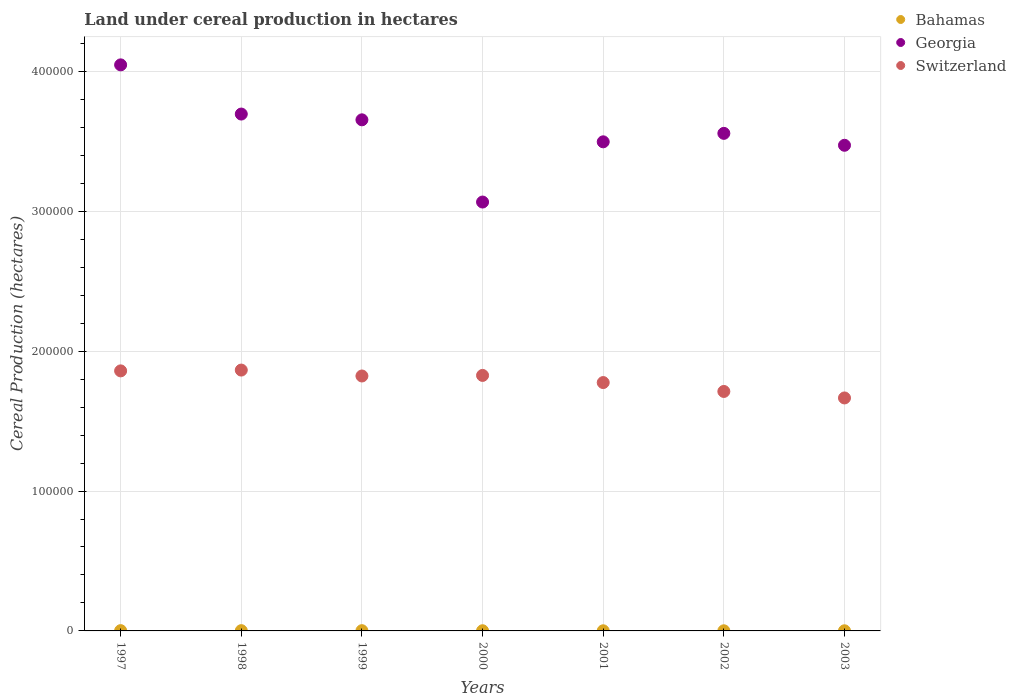What is the land under cereal production in Bahamas in 1998?
Ensure brevity in your answer.  190. Across all years, what is the maximum land under cereal production in Bahamas?
Make the answer very short. 200. Across all years, what is the minimum land under cereal production in Bahamas?
Keep it short and to the point. 100. In which year was the land under cereal production in Switzerland maximum?
Keep it short and to the point. 1998. What is the total land under cereal production in Georgia in the graph?
Provide a short and direct response. 2.50e+06. What is the difference between the land under cereal production in Bahamas in 1997 and that in 2002?
Your answer should be compact. 100. What is the difference between the land under cereal production in Bahamas in 1999 and the land under cereal production in Switzerland in 2001?
Provide a short and direct response. -1.77e+05. What is the average land under cereal production in Georgia per year?
Offer a terse response. 3.57e+05. In the year 2000, what is the difference between the land under cereal production in Georgia and land under cereal production in Switzerland?
Ensure brevity in your answer.  1.24e+05. What is the ratio of the land under cereal production in Georgia in 1998 to that in 1999?
Provide a short and direct response. 1.01. Is the difference between the land under cereal production in Georgia in 1999 and 2000 greater than the difference between the land under cereal production in Switzerland in 1999 and 2000?
Provide a succinct answer. Yes. What is the difference between the highest and the second highest land under cereal production in Switzerland?
Ensure brevity in your answer.  582. What is the difference between the highest and the lowest land under cereal production in Switzerland?
Provide a succinct answer. 1.99e+04. In how many years, is the land under cereal production in Georgia greater than the average land under cereal production in Georgia taken over all years?
Provide a succinct answer. 3. Is it the case that in every year, the sum of the land under cereal production in Bahamas and land under cereal production in Georgia  is greater than the land under cereal production in Switzerland?
Keep it short and to the point. Yes. Is the land under cereal production in Switzerland strictly greater than the land under cereal production in Georgia over the years?
Keep it short and to the point. No. Is the land under cereal production in Georgia strictly less than the land under cereal production in Bahamas over the years?
Your answer should be compact. No. How many dotlines are there?
Provide a short and direct response. 3. Are the values on the major ticks of Y-axis written in scientific E-notation?
Your answer should be compact. No. Does the graph contain any zero values?
Keep it short and to the point. No. Does the graph contain grids?
Offer a terse response. Yes. Where does the legend appear in the graph?
Give a very brief answer. Top right. How many legend labels are there?
Your response must be concise. 3. How are the legend labels stacked?
Offer a very short reply. Vertical. What is the title of the graph?
Offer a very short reply. Land under cereal production in hectares. What is the label or title of the Y-axis?
Provide a short and direct response. Cereal Production (hectares). What is the Cereal Production (hectares) in Georgia in 1997?
Provide a succinct answer. 4.05e+05. What is the Cereal Production (hectares) in Switzerland in 1997?
Provide a succinct answer. 1.86e+05. What is the Cereal Production (hectares) of Bahamas in 1998?
Provide a short and direct response. 190. What is the Cereal Production (hectares) in Georgia in 1998?
Your answer should be very brief. 3.70e+05. What is the Cereal Production (hectares) in Switzerland in 1998?
Offer a terse response. 1.86e+05. What is the Cereal Production (hectares) of Bahamas in 1999?
Ensure brevity in your answer.  175. What is the Cereal Production (hectares) in Georgia in 1999?
Offer a very short reply. 3.65e+05. What is the Cereal Production (hectares) in Switzerland in 1999?
Your response must be concise. 1.82e+05. What is the Cereal Production (hectares) of Bahamas in 2000?
Your answer should be compact. 126. What is the Cereal Production (hectares) in Georgia in 2000?
Offer a terse response. 3.07e+05. What is the Cereal Production (hectares) in Switzerland in 2000?
Offer a very short reply. 1.83e+05. What is the Cereal Production (hectares) in Georgia in 2001?
Offer a very short reply. 3.50e+05. What is the Cereal Production (hectares) of Switzerland in 2001?
Offer a terse response. 1.78e+05. What is the Cereal Production (hectares) in Bahamas in 2002?
Offer a terse response. 100. What is the Cereal Production (hectares) in Georgia in 2002?
Keep it short and to the point. 3.56e+05. What is the Cereal Production (hectares) in Switzerland in 2002?
Make the answer very short. 1.71e+05. What is the Cereal Production (hectares) in Georgia in 2003?
Give a very brief answer. 3.47e+05. What is the Cereal Production (hectares) of Switzerland in 2003?
Ensure brevity in your answer.  1.67e+05. Across all years, what is the maximum Cereal Production (hectares) of Bahamas?
Provide a short and direct response. 200. Across all years, what is the maximum Cereal Production (hectares) in Georgia?
Offer a terse response. 4.05e+05. Across all years, what is the maximum Cereal Production (hectares) of Switzerland?
Give a very brief answer. 1.86e+05. Across all years, what is the minimum Cereal Production (hectares) in Georgia?
Give a very brief answer. 3.07e+05. Across all years, what is the minimum Cereal Production (hectares) in Switzerland?
Your answer should be compact. 1.67e+05. What is the total Cereal Production (hectares) of Bahamas in the graph?
Offer a very short reply. 991. What is the total Cereal Production (hectares) of Georgia in the graph?
Your answer should be very brief. 2.50e+06. What is the total Cereal Production (hectares) of Switzerland in the graph?
Provide a short and direct response. 1.25e+06. What is the difference between the Cereal Production (hectares) of Georgia in 1997 and that in 1998?
Make the answer very short. 3.52e+04. What is the difference between the Cereal Production (hectares) of Switzerland in 1997 and that in 1998?
Make the answer very short. -582. What is the difference between the Cereal Production (hectares) in Bahamas in 1997 and that in 1999?
Provide a succinct answer. 25. What is the difference between the Cereal Production (hectares) in Georgia in 1997 and that in 1999?
Your answer should be compact. 3.93e+04. What is the difference between the Cereal Production (hectares) of Switzerland in 1997 and that in 1999?
Your answer should be compact. 3652. What is the difference between the Cereal Production (hectares) in Georgia in 1997 and that in 2000?
Your response must be concise. 9.81e+04. What is the difference between the Cereal Production (hectares) of Switzerland in 1997 and that in 2000?
Your response must be concise. 3243. What is the difference between the Cereal Production (hectares) in Bahamas in 1997 and that in 2001?
Offer a very short reply. 100. What is the difference between the Cereal Production (hectares) of Georgia in 1997 and that in 2001?
Offer a very short reply. 5.50e+04. What is the difference between the Cereal Production (hectares) in Switzerland in 1997 and that in 2001?
Ensure brevity in your answer.  8353. What is the difference between the Cereal Production (hectares) of Georgia in 1997 and that in 2002?
Your response must be concise. 4.90e+04. What is the difference between the Cereal Production (hectares) of Switzerland in 1997 and that in 2002?
Provide a short and direct response. 1.47e+04. What is the difference between the Cereal Production (hectares) of Georgia in 1997 and that in 2003?
Ensure brevity in your answer.  5.75e+04. What is the difference between the Cereal Production (hectares) in Switzerland in 1997 and that in 2003?
Make the answer very short. 1.94e+04. What is the difference between the Cereal Production (hectares) in Bahamas in 1998 and that in 1999?
Give a very brief answer. 15. What is the difference between the Cereal Production (hectares) in Georgia in 1998 and that in 1999?
Keep it short and to the point. 4126. What is the difference between the Cereal Production (hectares) of Switzerland in 1998 and that in 1999?
Offer a terse response. 4234. What is the difference between the Cereal Production (hectares) in Georgia in 1998 and that in 2000?
Make the answer very short. 6.29e+04. What is the difference between the Cereal Production (hectares) of Switzerland in 1998 and that in 2000?
Make the answer very short. 3825. What is the difference between the Cereal Production (hectares) in Georgia in 1998 and that in 2001?
Provide a succinct answer. 1.99e+04. What is the difference between the Cereal Production (hectares) of Switzerland in 1998 and that in 2001?
Offer a terse response. 8935. What is the difference between the Cereal Production (hectares) of Bahamas in 1998 and that in 2002?
Your response must be concise. 90. What is the difference between the Cereal Production (hectares) in Georgia in 1998 and that in 2002?
Make the answer very short. 1.38e+04. What is the difference between the Cereal Production (hectares) of Switzerland in 1998 and that in 2002?
Your answer should be compact. 1.53e+04. What is the difference between the Cereal Production (hectares) in Bahamas in 1998 and that in 2003?
Keep it short and to the point. 90. What is the difference between the Cereal Production (hectares) of Georgia in 1998 and that in 2003?
Provide a short and direct response. 2.23e+04. What is the difference between the Cereal Production (hectares) in Switzerland in 1998 and that in 2003?
Your response must be concise. 1.99e+04. What is the difference between the Cereal Production (hectares) of Bahamas in 1999 and that in 2000?
Make the answer very short. 49. What is the difference between the Cereal Production (hectares) of Georgia in 1999 and that in 2000?
Offer a terse response. 5.88e+04. What is the difference between the Cereal Production (hectares) of Switzerland in 1999 and that in 2000?
Provide a succinct answer. -409. What is the difference between the Cereal Production (hectares) of Bahamas in 1999 and that in 2001?
Provide a succinct answer. 75. What is the difference between the Cereal Production (hectares) in Georgia in 1999 and that in 2001?
Your answer should be compact. 1.57e+04. What is the difference between the Cereal Production (hectares) in Switzerland in 1999 and that in 2001?
Offer a terse response. 4701. What is the difference between the Cereal Production (hectares) of Georgia in 1999 and that in 2002?
Your answer should be very brief. 9676. What is the difference between the Cereal Production (hectares) in Switzerland in 1999 and that in 2002?
Give a very brief answer. 1.11e+04. What is the difference between the Cereal Production (hectares) of Georgia in 1999 and that in 2003?
Your response must be concise. 1.82e+04. What is the difference between the Cereal Production (hectares) of Switzerland in 1999 and that in 2003?
Make the answer very short. 1.57e+04. What is the difference between the Cereal Production (hectares) in Georgia in 2000 and that in 2001?
Give a very brief answer. -4.31e+04. What is the difference between the Cereal Production (hectares) in Switzerland in 2000 and that in 2001?
Your response must be concise. 5110. What is the difference between the Cereal Production (hectares) in Bahamas in 2000 and that in 2002?
Your response must be concise. 26. What is the difference between the Cereal Production (hectares) of Georgia in 2000 and that in 2002?
Provide a short and direct response. -4.91e+04. What is the difference between the Cereal Production (hectares) of Switzerland in 2000 and that in 2002?
Your answer should be compact. 1.15e+04. What is the difference between the Cereal Production (hectares) in Georgia in 2000 and that in 2003?
Provide a short and direct response. -4.06e+04. What is the difference between the Cereal Production (hectares) in Switzerland in 2000 and that in 2003?
Offer a very short reply. 1.61e+04. What is the difference between the Cereal Production (hectares) in Bahamas in 2001 and that in 2002?
Offer a very short reply. 0. What is the difference between the Cereal Production (hectares) in Georgia in 2001 and that in 2002?
Provide a short and direct response. -6049. What is the difference between the Cereal Production (hectares) of Switzerland in 2001 and that in 2002?
Provide a succinct answer. 6356. What is the difference between the Cereal Production (hectares) in Bahamas in 2001 and that in 2003?
Keep it short and to the point. 0. What is the difference between the Cereal Production (hectares) in Georgia in 2001 and that in 2003?
Your response must be concise. 2472. What is the difference between the Cereal Production (hectares) in Switzerland in 2001 and that in 2003?
Give a very brief answer. 1.10e+04. What is the difference between the Cereal Production (hectares) of Georgia in 2002 and that in 2003?
Your answer should be very brief. 8521. What is the difference between the Cereal Production (hectares) in Switzerland in 2002 and that in 2003?
Ensure brevity in your answer.  4642. What is the difference between the Cereal Production (hectares) in Bahamas in 1997 and the Cereal Production (hectares) in Georgia in 1998?
Provide a succinct answer. -3.69e+05. What is the difference between the Cereal Production (hectares) of Bahamas in 1997 and the Cereal Production (hectares) of Switzerland in 1998?
Offer a very short reply. -1.86e+05. What is the difference between the Cereal Production (hectares) of Georgia in 1997 and the Cereal Production (hectares) of Switzerland in 1998?
Provide a short and direct response. 2.18e+05. What is the difference between the Cereal Production (hectares) of Bahamas in 1997 and the Cereal Production (hectares) of Georgia in 1999?
Provide a short and direct response. -3.65e+05. What is the difference between the Cereal Production (hectares) in Bahamas in 1997 and the Cereal Production (hectares) in Switzerland in 1999?
Your answer should be very brief. -1.82e+05. What is the difference between the Cereal Production (hectares) in Georgia in 1997 and the Cereal Production (hectares) in Switzerland in 1999?
Keep it short and to the point. 2.22e+05. What is the difference between the Cereal Production (hectares) of Bahamas in 1997 and the Cereal Production (hectares) of Georgia in 2000?
Give a very brief answer. -3.06e+05. What is the difference between the Cereal Production (hectares) of Bahamas in 1997 and the Cereal Production (hectares) of Switzerland in 2000?
Ensure brevity in your answer.  -1.82e+05. What is the difference between the Cereal Production (hectares) in Georgia in 1997 and the Cereal Production (hectares) in Switzerland in 2000?
Provide a succinct answer. 2.22e+05. What is the difference between the Cereal Production (hectares) of Bahamas in 1997 and the Cereal Production (hectares) of Georgia in 2001?
Your answer should be very brief. -3.49e+05. What is the difference between the Cereal Production (hectares) in Bahamas in 1997 and the Cereal Production (hectares) in Switzerland in 2001?
Make the answer very short. -1.77e+05. What is the difference between the Cereal Production (hectares) of Georgia in 1997 and the Cereal Production (hectares) of Switzerland in 2001?
Your response must be concise. 2.27e+05. What is the difference between the Cereal Production (hectares) of Bahamas in 1997 and the Cereal Production (hectares) of Georgia in 2002?
Your answer should be compact. -3.56e+05. What is the difference between the Cereal Production (hectares) in Bahamas in 1997 and the Cereal Production (hectares) in Switzerland in 2002?
Ensure brevity in your answer.  -1.71e+05. What is the difference between the Cereal Production (hectares) of Georgia in 1997 and the Cereal Production (hectares) of Switzerland in 2002?
Provide a short and direct response. 2.33e+05. What is the difference between the Cereal Production (hectares) in Bahamas in 1997 and the Cereal Production (hectares) in Georgia in 2003?
Give a very brief answer. -3.47e+05. What is the difference between the Cereal Production (hectares) in Bahamas in 1997 and the Cereal Production (hectares) in Switzerland in 2003?
Provide a succinct answer. -1.66e+05. What is the difference between the Cereal Production (hectares) in Georgia in 1997 and the Cereal Production (hectares) in Switzerland in 2003?
Your answer should be compact. 2.38e+05. What is the difference between the Cereal Production (hectares) of Bahamas in 1998 and the Cereal Production (hectares) of Georgia in 1999?
Give a very brief answer. -3.65e+05. What is the difference between the Cereal Production (hectares) in Bahamas in 1998 and the Cereal Production (hectares) in Switzerland in 1999?
Ensure brevity in your answer.  -1.82e+05. What is the difference between the Cereal Production (hectares) of Georgia in 1998 and the Cereal Production (hectares) of Switzerland in 1999?
Keep it short and to the point. 1.87e+05. What is the difference between the Cereal Production (hectares) of Bahamas in 1998 and the Cereal Production (hectares) of Georgia in 2000?
Your response must be concise. -3.06e+05. What is the difference between the Cereal Production (hectares) in Bahamas in 1998 and the Cereal Production (hectares) in Switzerland in 2000?
Your answer should be very brief. -1.82e+05. What is the difference between the Cereal Production (hectares) of Georgia in 1998 and the Cereal Production (hectares) of Switzerland in 2000?
Your response must be concise. 1.87e+05. What is the difference between the Cereal Production (hectares) in Bahamas in 1998 and the Cereal Production (hectares) in Georgia in 2001?
Offer a terse response. -3.49e+05. What is the difference between the Cereal Production (hectares) of Bahamas in 1998 and the Cereal Production (hectares) of Switzerland in 2001?
Give a very brief answer. -1.77e+05. What is the difference between the Cereal Production (hectares) of Georgia in 1998 and the Cereal Production (hectares) of Switzerland in 2001?
Provide a succinct answer. 1.92e+05. What is the difference between the Cereal Production (hectares) of Bahamas in 1998 and the Cereal Production (hectares) of Georgia in 2002?
Your response must be concise. -3.56e+05. What is the difference between the Cereal Production (hectares) of Bahamas in 1998 and the Cereal Production (hectares) of Switzerland in 2002?
Your answer should be compact. -1.71e+05. What is the difference between the Cereal Production (hectares) of Georgia in 1998 and the Cereal Production (hectares) of Switzerland in 2002?
Keep it short and to the point. 1.98e+05. What is the difference between the Cereal Production (hectares) of Bahamas in 1998 and the Cereal Production (hectares) of Georgia in 2003?
Your answer should be compact. -3.47e+05. What is the difference between the Cereal Production (hectares) in Bahamas in 1998 and the Cereal Production (hectares) in Switzerland in 2003?
Your response must be concise. -1.66e+05. What is the difference between the Cereal Production (hectares) of Georgia in 1998 and the Cereal Production (hectares) of Switzerland in 2003?
Your answer should be compact. 2.03e+05. What is the difference between the Cereal Production (hectares) of Bahamas in 1999 and the Cereal Production (hectares) of Georgia in 2000?
Offer a terse response. -3.06e+05. What is the difference between the Cereal Production (hectares) in Bahamas in 1999 and the Cereal Production (hectares) in Switzerland in 2000?
Keep it short and to the point. -1.82e+05. What is the difference between the Cereal Production (hectares) in Georgia in 1999 and the Cereal Production (hectares) in Switzerland in 2000?
Give a very brief answer. 1.83e+05. What is the difference between the Cereal Production (hectares) of Bahamas in 1999 and the Cereal Production (hectares) of Georgia in 2001?
Offer a terse response. -3.49e+05. What is the difference between the Cereal Production (hectares) in Bahamas in 1999 and the Cereal Production (hectares) in Switzerland in 2001?
Your answer should be very brief. -1.77e+05. What is the difference between the Cereal Production (hectares) in Georgia in 1999 and the Cereal Production (hectares) in Switzerland in 2001?
Keep it short and to the point. 1.88e+05. What is the difference between the Cereal Production (hectares) in Bahamas in 1999 and the Cereal Production (hectares) in Georgia in 2002?
Your answer should be very brief. -3.56e+05. What is the difference between the Cereal Production (hectares) in Bahamas in 1999 and the Cereal Production (hectares) in Switzerland in 2002?
Make the answer very short. -1.71e+05. What is the difference between the Cereal Production (hectares) of Georgia in 1999 and the Cereal Production (hectares) of Switzerland in 2002?
Give a very brief answer. 1.94e+05. What is the difference between the Cereal Production (hectares) in Bahamas in 1999 and the Cereal Production (hectares) in Georgia in 2003?
Your answer should be very brief. -3.47e+05. What is the difference between the Cereal Production (hectares) of Bahamas in 1999 and the Cereal Production (hectares) of Switzerland in 2003?
Your answer should be compact. -1.66e+05. What is the difference between the Cereal Production (hectares) of Georgia in 1999 and the Cereal Production (hectares) of Switzerland in 2003?
Provide a succinct answer. 1.99e+05. What is the difference between the Cereal Production (hectares) in Bahamas in 2000 and the Cereal Production (hectares) in Georgia in 2001?
Your answer should be very brief. -3.50e+05. What is the difference between the Cereal Production (hectares) in Bahamas in 2000 and the Cereal Production (hectares) in Switzerland in 2001?
Make the answer very short. -1.77e+05. What is the difference between the Cereal Production (hectares) of Georgia in 2000 and the Cereal Production (hectares) of Switzerland in 2001?
Provide a short and direct response. 1.29e+05. What is the difference between the Cereal Production (hectares) of Bahamas in 2000 and the Cereal Production (hectares) of Georgia in 2002?
Give a very brief answer. -3.56e+05. What is the difference between the Cereal Production (hectares) in Bahamas in 2000 and the Cereal Production (hectares) in Switzerland in 2002?
Make the answer very short. -1.71e+05. What is the difference between the Cereal Production (hectares) of Georgia in 2000 and the Cereal Production (hectares) of Switzerland in 2002?
Your answer should be compact. 1.35e+05. What is the difference between the Cereal Production (hectares) of Bahamas in 2000 and the Cereal Production (hectares) of Georgia in 2003?
Give a very brief answer. -3.47e+05. What is the difference between the Cereal Production (hectares) in Bahamas in 2000 and the Cereal Production (hectares) in Switzerland in 2003?
Give a very brief answer. -1.66e+05. What is the difference between the Cereal Production (hectares) of Georgia in 2000 and the Cereal Production (hectares) of Switzerland in 2003?
Your answer should be very brief. 1.40e+05. What is the difference between the Cereal Production (hectares) in Bahamas in 2001 and the Cereal Production (hectares) in Georgia in 2002?
Provide a succinct answer. -3.56e+05. What is the difference between the Cereal Production (hectares) of Bahamas in 2001 and the Cereal Production (hectares) of Switzerland in 2002?
Make the answer very short. -1.71e+05. What is the difference between the Cereal Production (hectares) in Georgia in 2001 and the Cereal Production (hectares) in Switzerland in 2002?
Keep it short and to the point. 1.78e+05. What is the difference between the Cereal Production (hectares) in Bahamas in 2001 and the Cereal Production (hectares) in Georgia in 2003?
Ensure brevity in your answer.  -3.47e+05. What is the difference between the Cereal Production (hectares) in Bahamas in 2001 and the Cereal Production (hectares) in Switzerland in 2003?
Your answer should be very brief. -1.66e+05. What is the difference between the Cereal Production (hectares) in Georgia in 2001 and the Cereal Production (hectares) in Switzerland in 2003?
Provide a succinct answer. 1.83e+05. What is the difference between the Cereal Production (hectares) of Bahamas in 2002 and the Cereal Production (hectares) of Georgia in 2003?
Provide a succinct answer. -3.47e+05. What is the difference between the Cereal Production (hectares) in Bahamas in 2002 and the Cereal Production (hectares) in Switzerland in 2003?
Ensure brevity in your answer.  -1.66e+05. What is the difference between the Cereal Production (hectares) in Georgia in 2002 and the Cereal Production (hectares) in Switzerland in 2003?
Your response must be concise. 1.89e+05. What is the average Cereal Production (hectares) in Bahamas per year?
Your response must be concise. 141.57. What is the average Cereal Production (hectares) of Georgia per year?
Provide a succinct answer. 3.57e+05. What is the average Cereal Production (hectares) in Switzerland per year?
Your answer should be very brief. 1.79e+05. In the year 1997, what is the difference between the Cereal Production (hectares) of Bahamas and Cereal Production (hectares) of Georgia?
Give a very brief answer. -4.04e+05. In the year 1997, what is the difference between the Cereal Production (hectares) of Bahamas and Cereal Production (hectares) of Switzerland?
Provide a succinct answer. -1.86e+05. In the year 1997, what is the difference between the Cereal Production (hectares) in Georgia and Cereal Production (hectares) in Switzerland?
Provide a short and direct response. 2.19e+05. In the year 1998, what is the difference between the Cereal Production (hectares) in Bahamas and Cereal Production (hectares) in Georgia?
Your answer should be compact. -3.69e+05. In the year 1998, what is the difference between the Cereal Production (hectares) in Bahamas and Cereal Production (hectares) in Switzerland?
Ensure brevity in your answer.  -1.86e+05. In the year 1998, what is the difference between the Cereal Production (hectares) in Georgia and Cereal Production (hectares) in Switzerland?
Make the answer very short. 1.83e+05. In the year 1999, what is the difference between the Cereal Production (hectares) of Bahamas and Cereal Production (hectares) of Georgia?
Keep it short and to the point. -3.65e+05. In the year 1999, what is the difference between the Cereal Production (hectares) in Bahamas and Cereal Production (hectares) in Switzerland?
Make the answer very short. -1.82e+05. In the year 1999, what is the difference between the Cereal Production (hectares) of Georgia and Cereal Production (hectares) of Switzerland?
Provide a succinct answer. 1.83e+05. In the year 2000, what is the difference between the Cereal Production (hectares) of Bahamas and Cereal Production (hectares) of Georgia?
Give a very brief answer. -3.06e+05. In the year 2000, what is the difference between the Cereal Production (hectares) in Bahamas and Cereal Production (hectares) in Switzerland?
Offer a very short reply. -1.83e+05. In the year 2000, what is the difference between the Cereal Production (hectares) of Georgia and Cereal Production (hectares) of Switzerland?
Your answer should be compact. 1.24e+05. In the year 2001, what is the difference between the Cereal Production (hectares) in Bahamas and Cereal Production (hectares) in Georgia?
Make the answer very short. -3.50e+05. In the year 2001, what is the difference between the Cereal Production (hectares) in Bahamas and Cereal Production (hectares) in Switzerland?
Make the answer very short. -1.77e+05. In the year 2001, what is the difference between the Cereal Production (hectares) of Georgia and Cereal Production (hectares) of Switzerland?
Provide a short and direct response. 1.72e+05. In the year 2002, what is the difference between the Cereal Production (hectares) in Bahamas and Cereal Production (hectares) in Georgia?
Offer a very short reply. -3.56e+05. In the year 2002, what is the difference between the Cereal Production (hectares) in Bahamas and Cereal Production (hectares) in Switzerland?
Give a very brief answer. -1.71e+05. In the year 2002, what is the difference between the Cereal Production (hectares) of Georgia and Cereal Production (hectares) of Switzerland?
Your response must be concise. 1.85e+05. In the year 2003, what is the difference between the Cereal Production (hectares) of Bahamas and Cereal Production (hectares) of Georgia?
Make the answer very short. -3.47e+05. In the year 2003, what is the difference between the Cereal Production (hectares) in Bahamas and Cereal Production (hectares) in Switzerland?
Offer a terse response. -1.66e+05. In the year 2003, what is the difference between the Cereal Production (hectares) in Georgia and Cereal Production (hectares) in Switzerland?
Offer a very short reply. 1.81e+05. What is the ratio of the Cereal Production (hectares) in Bahamas in 1997 to that in 1998?
Provide a short and direct response. 1.05. What is the ratio of the Cereal Production (hectares) of Georgia in 1997 to that in 1998?
Your response must be concise. 1.1. What is the ratio of the Cereal Production (hectares) in Switzerland in 1997 to that in 1998?
Provide a short and direct response. 1. What is the ratio of the Cereal Production (hectares) of Georgia in 1997 to that in 1999?
Provide a short and direct response. 1.11. What is the ratio of the Cereal Production (hectares) of Bahamas in 1997 to that in 2000?
Keep it short and to the point. 1.59. What is the ratio of the Cereal Production (hectares) of Georgia in 1997 to that in 2000?
Your response must be concise. 1.32. What is the ratio of the Cereal Production (hectares) of Switzerland in 1997 to that in 2000?
Ensure brevity in your answer.  1.02. What is the ratio of the Cereal Production (hectares) of Georgia in 1997 to that in 2001?
Your answer should be very brief. 1.16. What is the ratio of the Cereal Production (hectares) in Switzerland in 1997 to that in 2001?
Offer a very short reply. 1.05. What is the ratio of the Cereal Production (hectares) in Georgia in 1997 to that in 2002?
Offer a terse response. 1.14. What is the ratio of the Cereal Production (hectares) in Switzerland in 1997 to that in 2002?
Keep it short and to the point. 1.09. What is the ratio of the Cereal Production (hectares) of Georgia in 1997 to that in 2003?
Provide a succinct answer. 1.17. What is the ratio of the Cereal Production (hectares) of Switzerland in 1997 to that in 2003?
Keep it short and to the point. 1.12. What is the ratio of the Cereal Production (hectares) of Bahamas in 1998 to that in 1999?
Keep it short and to the point. 1.09. What is the ratio of the Cereal Production (hectares) of Georgia in 1998 to that in 1999?
Your answer should be very brief. 1.01. What is the ratio of the Cereal Production (hectares) of Switzerland in 1998 to that in 1999?
Offer a very short reply. 1.02. What is the ratio of the Cereal Production (hectares) in Bahamas in 1998 to that in 2000?
Ensure brevity in your answer.  1.51. What is the ratio of the Cereal Production (hectares) of Georgia in 1998 to that in 2000?
Keep it short and to the point. 1.21. What is the ratio of the Cereal Production (hectares) in Switzerland in 1998 to that in 2000?
Ensure brevity in your answer.  1.02. What is the ratio of the Cereal Production (hectares) of Georgia in 1998 to that in 2001?
Your response must be concise. 1.06. What is the ratio of the Cereal Production (hectares) in Switzerland in 1998 to that in 2001?
Offer a terse response. 1.05. What is the ratio of the Cereal Production (hectares) of Georgia in 1998 to that in 2002?
Your answer should be compact. 1.04. What is the ratio of the Cereal Production (hectares) in Switzerland in 1998 to that in 2002?
Ensure brevity in your answer.  1.09. What is the ratio of the Cereal Production (hectares) of Georgia in 1998 to that in 2003?
Your answer should be very brief. 1.06. What is the ratio of the Cereal Production (hectares) in Switzerland in 1998 to that in 2003?
Your response must be concise. 1.12. What is the ratio of the Cereal Production (hectares) in Bahamas in 1999 to that in 2000?
Provide a succinct answer. 1.39. What is the ratio of the Cereal Production (hectares) in Georgia in 1999 to that in 2000?
Your response must be concise. 1.19. What is the ratio of the Cereal Production (hectares) of Bahamas in 1999 to that in 2001?
Give a very brief answer. 1.75. What is the ratio of the Cereal Production (hectares) of Georgia in 1999 to that in 2001?
Provide a succinct answer. 1.04. What is the ratio of the Cereal Production (hectares) in Switzerland in 1999 to that in 2001?
Your answer should be compact. 1.03. What is the ratio of the Cereal Production (hectares) in Bahamas in 1999 to that in 2002?
Your answer should be compact. 1.75. What is the ratio of the Cereal Production (hectares) of Georgia in 1999 to that in 2002?
Give a very brief answer. 1.03. What is the ratio of the Cereal Production (hectares) in Switzerland in 1999 to that in 2002?
Your answer should be compact. 1.06. What is the ratio of the Cereal Production (hectares) in Georgia in 1999 to that in 2003?
Your response must be concise. 1.05. What is the ratio of the Cereal Production (hectares) of Switzerland in 1999 to that in 2003?
Provide a short and direct response. 1.09. What is the ratio of the Cereal Production (hectares) of Bahamas in 2000 to that in 2001?
Your answer should be compact. 1.26. What is the ratio of the Cereal Production (hectares) of Georgia in 2000 to that in 2001?
Your answer should be compact. 0.88. What is the ratio of the Cereal Production (hectares) of Switzerland in 2000 to that in 2001?
Your answer should be compact. 1.03. What is the ratio of the Cereal Production (hectares) in Bahamas in 2000 to that in 2002?
Make the answer very short. 1.26. What is the ratio of the Cereal Production (hectares) of Georgia in 2000 to that in 2002?
Offer a very short reply. 0.86. What is the ratio of the Cereal Production (hectares) in Switzerland in 2000 to that in 2002?
Make the answer very short. 1.07. What is the ratio of the Cereal Production (hectares) in Bahamas in 2000 to that in 2003?
Ensure brevity in your answer.  1.26. What is the ratio of the Cereal Production (hectares) of Georgia in 2000 to that in 2003?
Give a very brief answer. 0.88. What is the ratio of the Cereal Production (hectares) in Switzerland in 2000 to that in 2003?
Your answer should be compact. 1.1. What is the ratio of the Cereal Production (hectares) in Bahamas in 2001 to that in 2002?
Give a very brief answer. 1. What is the ratio of the Cereal Production (hectares) in Georgia in 2001 to that in 2002?
Your answer should be very brief. 0.98. What is the ratio of the Cereal Production (hectares) in Switzerland in 2001 to that in 2002?
Provide a short and direct response. 1.04. What is the ratio of the Cereal Production (hectares) in Bahamas in 2001 to that in 2003?
Offer a terse response. 1. What is the ratio of the Cereal Production (hectares) in Georgia in 2001 to that in 2003?
Offer a terse response. 1.01. What is the ratio of the Cereal Production (hectares) in Switzerland in 2001 to that in 2003?
Offer a very short reply. 1.07. What is the ratio of the Cereal Production (hectares) of Bahamas in 2002 to that in 2003?
Offer a very short reply. 1. What is the ratio of the Cereal Production (hectares) in Georgia in 2002 to that in 2003?
Provide a succinct answer. 1.02. What is the ratio of the Cereal Production (hectares) of Switzerland in 2002 to that in 2003?
Your answer should be very brief. 1.03. What is the difference between the highest and the second highest Cereal Production (hectares) in Bahamas?
Give a very brief answer. 10. What is the difference between the highest and the second highest Cereal Production (hectares) in Georgia?
Provide a succinct answer. 3.52e+04. What is the difference between the highest and the second highest Cereal Production (hectares) in Switzerland?
Your answer should be compact. 582. What is the difference between the highest and the lowest Cereal Production (hectares) of Georgia?
Your response must be concise. 9.81e+04. What is the difference between the highest and the lowest Cereal Production (hectares) in Switzerland?
Ensure brevity in your answer.  1.99e+04. 